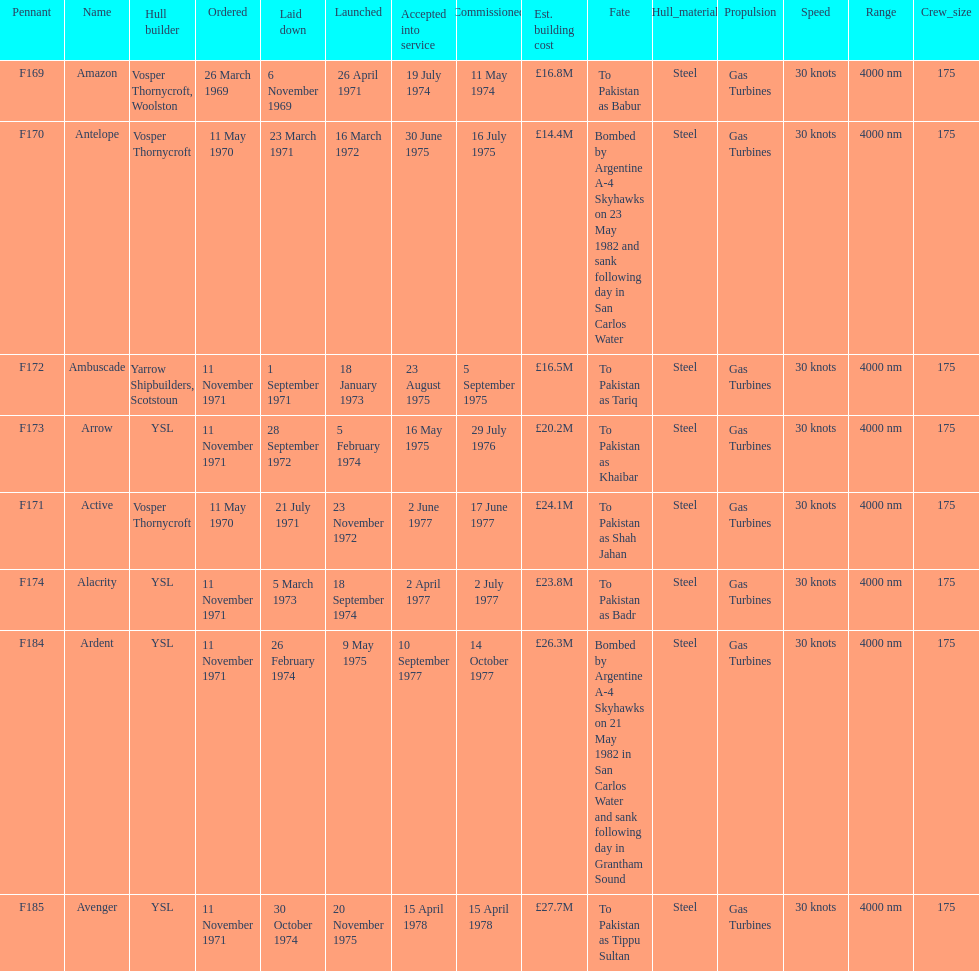How many ships were laid down in september? 2. 